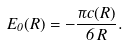<formula> <loc_0><loc_0><loc_500><loc_500>E _ { 0 } ( R ) = - \frac { \pi c ( R ) } { 6 \, R } .</formula> 